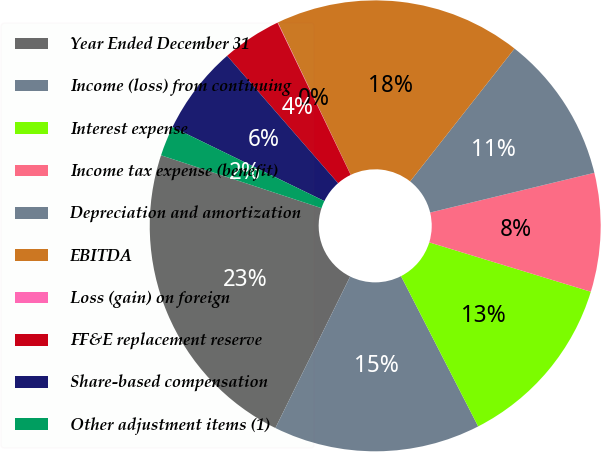Convert chart to OTSL. <chart><loc_0><loc_0><loc_500><loc_500><pie_chart><fcel>Year Ended December 31<fcel>Income (loss) from continuing<fcel>Interest expense<fcel>Income tax expense (benefit)<fcel>Depreciation and amortization<fcel>EBITDA<fcel>Loss (gain) on foreign<fcel>FF&E replacement reserve<fcel>Share-based compensation<fcel>Other adjustment items (1)<nl><fcel>22.77%<fcel>14.85%<fcel>12.73%<fcel>8.5%<fcel>10.62%<fcel>17.71%<fcel>0.03%<fcel>4.27%<fcel>6.38%<fcel>2.15%<nl></chart> 